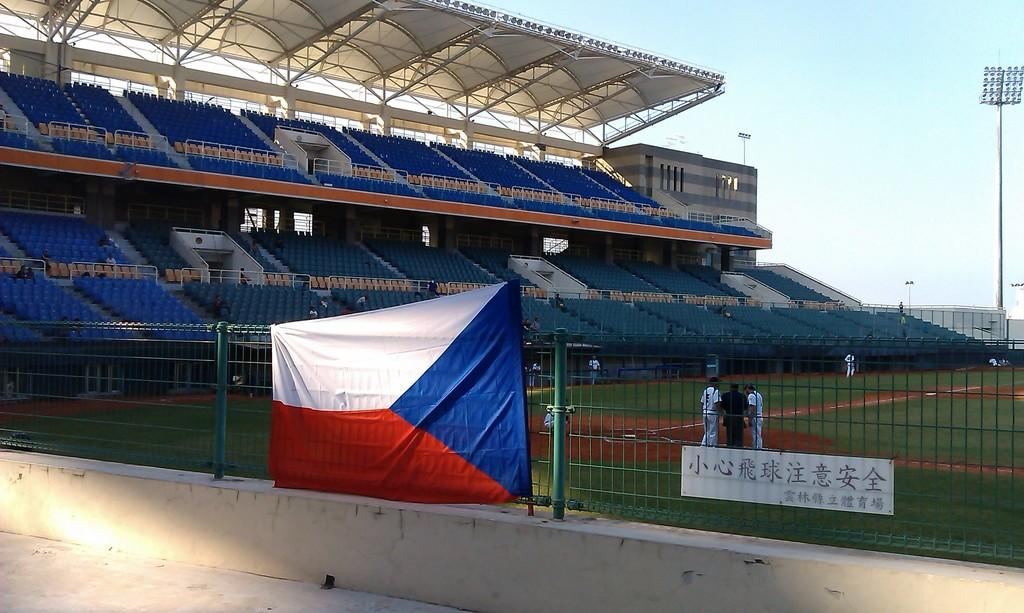<image>
Write a terse but informative summary of the picture. Player number 5 consults with an umpire and another player on the field. 